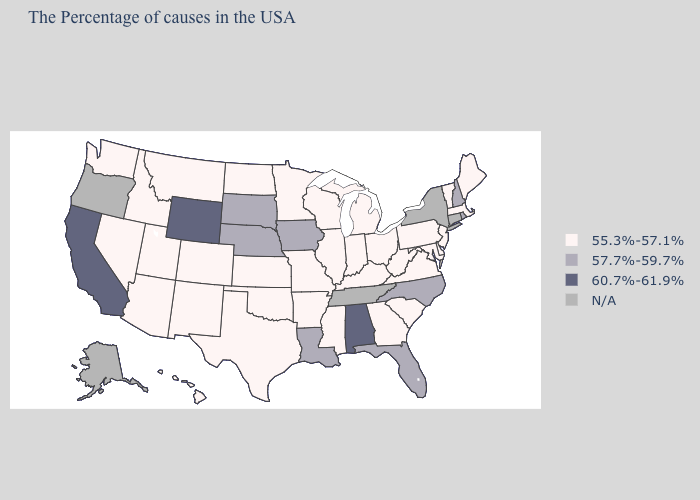Among the states that border Mississippi , does Louisiana have the lowest value?
Be succinct. No. Name the states that have a value in the range N/A?
Quick response, please. Connecticut, New York, Tennessee, Oregon, Alaska. Which states have the highest value in the USA?
Concise answer only. Alabama, Wyoming, California. What is the value of Oklahoma?
Answer briefly. 55.3%-57.1%. What is the value of Kansas?
Concise answer only. 55.3%-57.1%. What is the value of Alabama?
Quick response, please. 60.7%-61.9%. What is the value of Georgia?
Be succinct. 55.3%-57.1%. Among the states that border Iowa , does Nebraska have the highest value?
Write a very short answer. Yes. Name the states that have a value in the range 55.3%-57.1%?
Answer briefly. Maine, Massachusetts, Vermont, New Jersey, Delaware, Maryland, Pennsylvania, Virginia, South Carolina, West Virginia, Ohio, Georgia, Michigan, Kentucky, Indiana, Wisconsin, Illinois, Mississippi, Missouri, Arkansas, Minnesota, Kansas, Oklahoma, Texas, North Dakota, Colorado, New Mexico, Utah, Montana, Arizona, Idaho, Nevada, Washington, Hawaii. What is the lowest value in the USA?
Be succinct. 55.3%-57.1%. Which states have the lowest value in the USA?
Quick response, please. Maine, Massachusetts, Vermont, New Jersey, Delaware, Maryland, Pennsylvania, Virginia, South Carolina, West Virginia, Ohio, Georgia, Michigan, Kentucky, Indiana, Wisconsin, Illinois, Mississippi, Missouri, Arkansas, Minnesota, Kansas, Oklahoma, Texas, North Dakota, Colorado, New Mexico, Utah, Montana, Arizona, Idaho, Nevada, Washington, Hawaii. Does Utah have the highest value in the USA?
Write a very short answer. No. Among the states that border Oklahoma , which have the lowest value?
Concise answer only. Missouri, Arkansas, Kansas, Texas, Colorado, New Mexico. Which states have the lowest value in the West?
Quick response, please. Colorado, New Mexico, Utah, Montana, Arizona, Idaho, Nevada, Washington, Hawaii. 